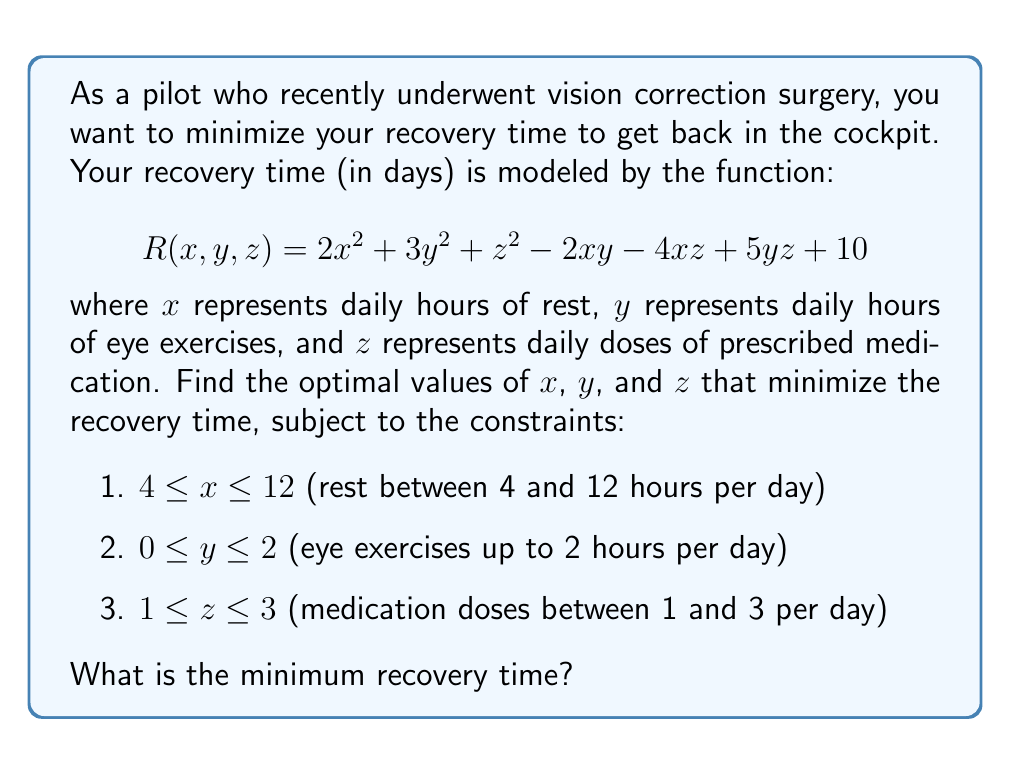Can you solve this math problem? To solve this optimization problem, we'll use the method of partial derivatives and the Karush-Kuhn-Tucker (KKT) conditions.

1) First, let's find the partial derivatives of $R$ with respect to $x$, $y$, and $z$:

   $$\frac{\partial R}{\partial x} = 4x - 2y - 4z$$
   $$\frac{\partial R}{\partial y} = 6y - 2x + 5z$$
   $$\frac{\partial R}{\partial z} = 2z - 4x + 5y$$

2) Set these partial derivatives to zero to find the critical points:

   $$4x - 2y - 4z = 0$$
   $$6y - 2x + 5z = 0$$
   $$2z - 4x + 5y = 0$$

3) Solve this system of equations:
   
   From the third equation: $z = 2x - \frac{5}{2}y$
   
   Substitute this into the first equation:
   $4x - 2y - 4(2x - \frac{5}{2}y) = 0$
   $4x - 2y - 8x + 5y = 0$
   $-4x + 3y = 0$
   $y = \frac{4}{3}x$

   Now substitute both of these into the second equation:
   $6(\frac{4}{3}x) - 2x + 5(2x - \frac{5}{2}\frac{4}{3}x) = 0$
   $8x - 2x + 10x - \frac{25}{3}x = 0$
   $16x - \frac{25}{3}x = 0$
   $\frac{23}{3}x = 0$
   $x = 0$

   Therefore, $y = 0$ and $z = 0$

4) However, this critical point $(0, 0, 0)$ is outside our constraints. So, we need to check the boundaries of our constraints:

   For $x$: 4 and 12
   For $y$: 0 and 2
   For $z$: 1 and 3

5) We need to check all combinations of these boundary values:

   $(4, 0, 1)$: $R = 2(4)^2 + 3(0)^2 + 1^2 - 2(4)(0) - 4(4)(1) + 5(0)(1) + 10 = 39$
   $(4, 0, 3)$: $R = 2(4)^2 + 3(0)^2 + 3^2 - 2(4)(0) - 4(4)(3) + 5(0)(3) + 10 = 41$
   $(4, 2, 1)$: $R = 2(4)^2 + 3(2)^2 + 1^2 - 2(4)(2) - 4(4)(1) + 5(2)(1) + 10 = 51$
   $(4, 2, 3)$: $R = 2(4)^2 + 3(2)^2 + 3^2 - 2(4)(2) - 4(4)(3) + 5(2)(3) + 10 = 61$
   $(12, 0, 1)$: $R = 2(12)^2 + 3(0)^2 + 1^2 - 2(12)(0) - 4(12)(1) + 5(0)(1) + 10 = 247$
   $(12, 0, 3)$: $R = 2(12)^2 + 3(0)^2 + 3^2 - 2(12)(0) - 4(12)(3) + 5(0)(3) + 10 = 201$
   $(12, 2, 1)$: $R = 2(12)^2 + 3(2)^2 + 1^2 - 2(12)(2) - 4(12)(1) + 5(2)(1) + 10 = 259$
   $(12, 2, 3)$: $R = 2(12)^2 + 3(2)^2 + 3^2 - 2(12)(2) - 4(12)(3) + 5(2)(3) + 10 = 221$

6) The minimum value among these is 39, which occurs at $(x, y, z) = (4, 0, 1)$.

Therefore, the optimal recovery plan is to rest for 4 hours per day, do no eye exercises, and take 1 dose of medication per day.
Answer: The minimum recovery time is 39 days, achieved with 4 hours of daily rest, 0 hours of eye exercises, and 1 dose of medication per day. 